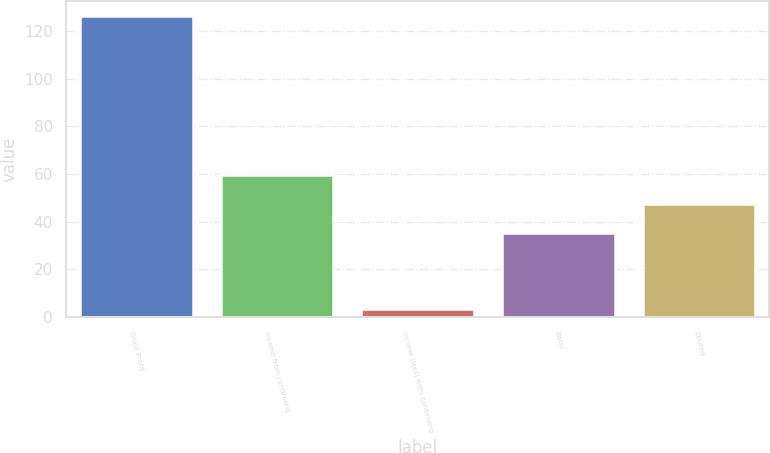<chart> <loc_0><loc_0><loc_500><loc_500><bar_chart><fcel>Gross Profit<fcel>Income from continuing<fcel>Income (loss) from continuing<fcel>Basic<fcel>Diluted<nl><fcel>126.1<fcel>59.74<fcel>3.4<fcel>35.2<fcel>47.47<nl></chart> 